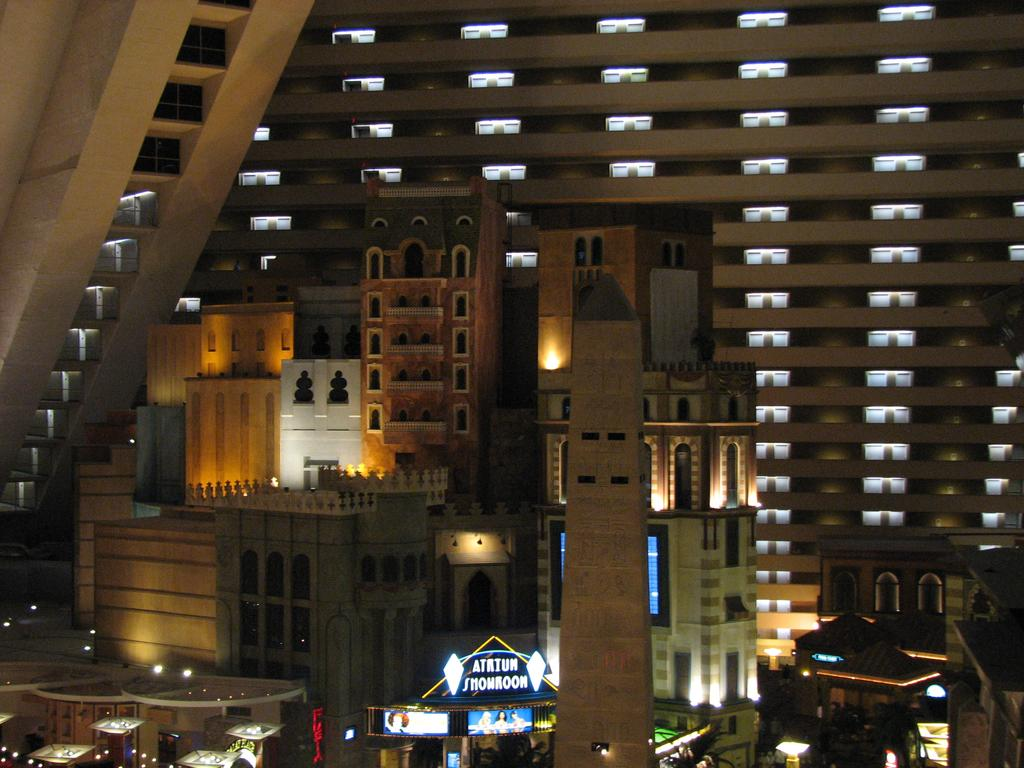What type of structures can be seen in the image? There are multiple buildings in the image. What architectural features are visible on the buildings? There are multiple windows visible in the image. What type of illumination is present in the image? There are lights present in the image. What is located at the bottom of the image? There are boards at the bottom of the image. What is written on the boards? Words are written on the boards. What type of treatment is the daughter receiving in the image? There is no daughter present in the image, and therefore no treatment can be observed. What type of tree can be seen in the image? There is no tree present in the image. 